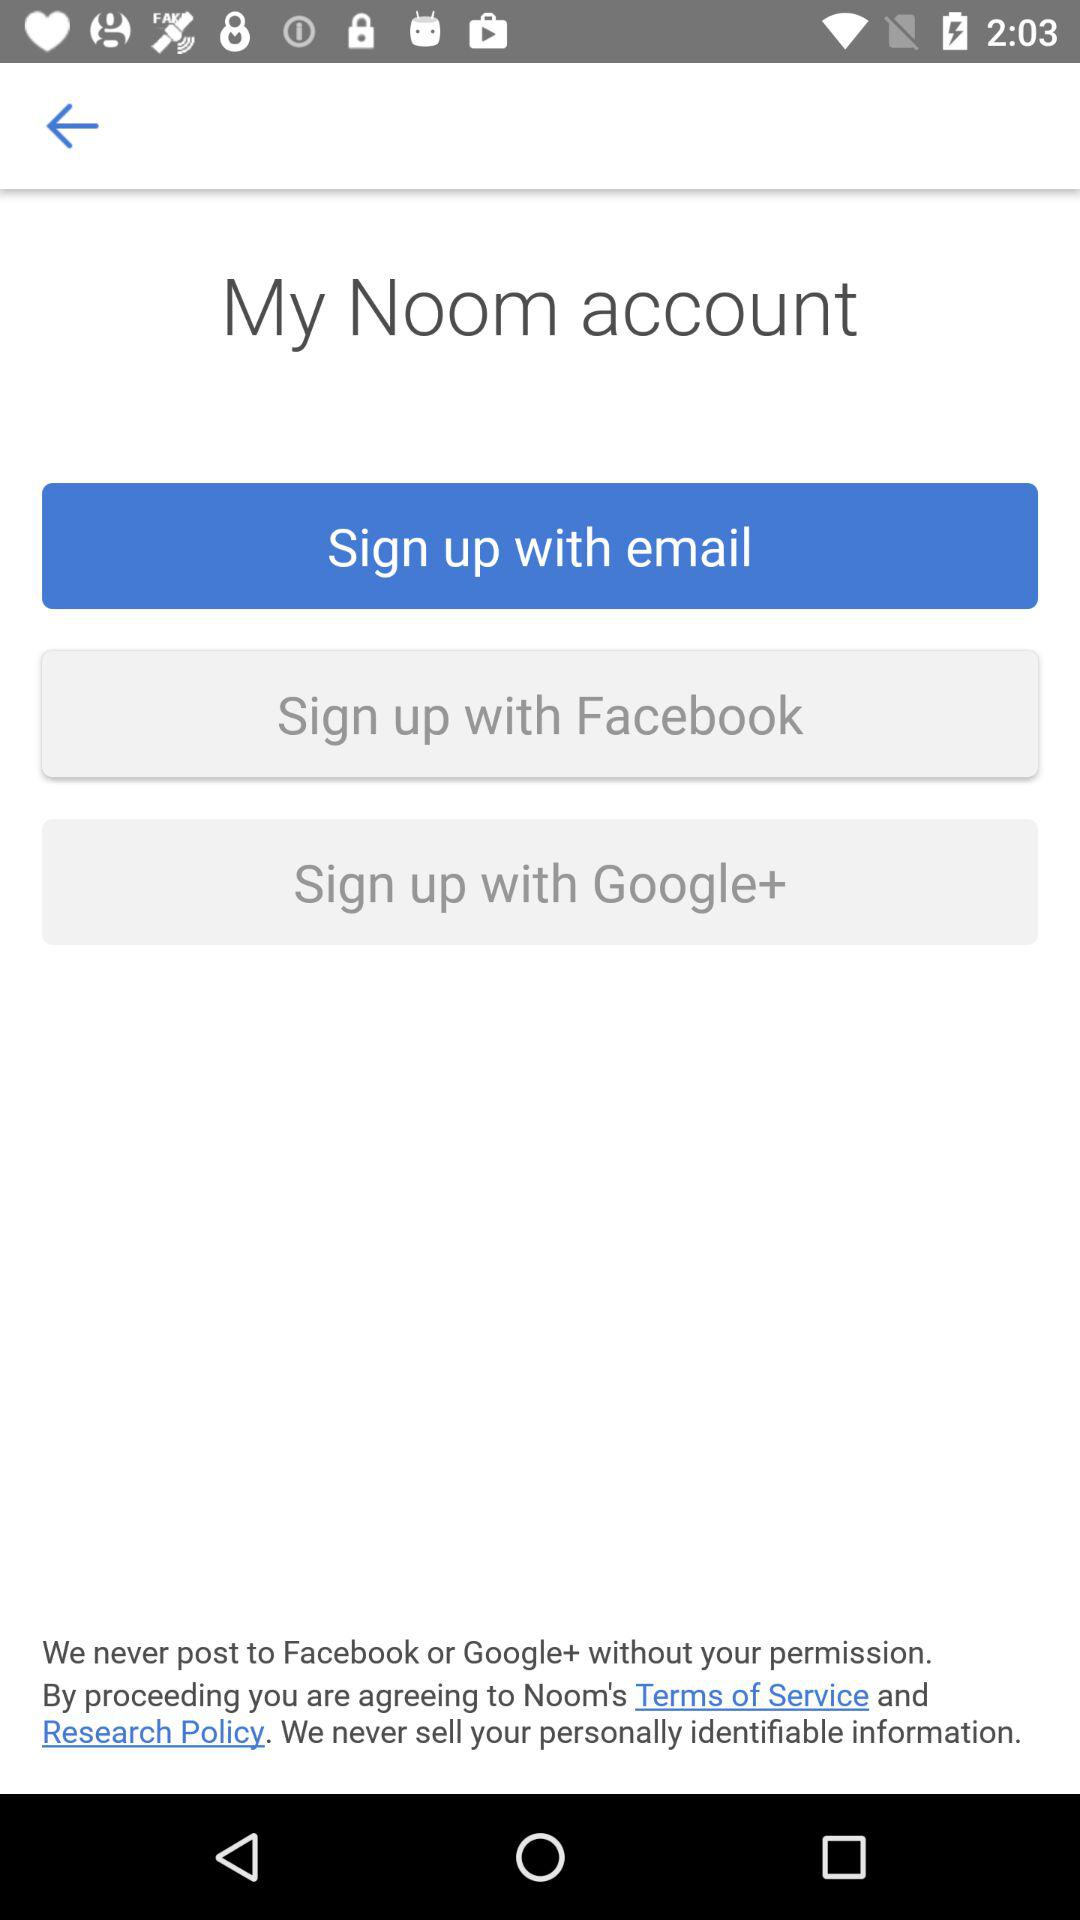Which applications can we use to sign up? The applications are "Facebook" and "Google+". 